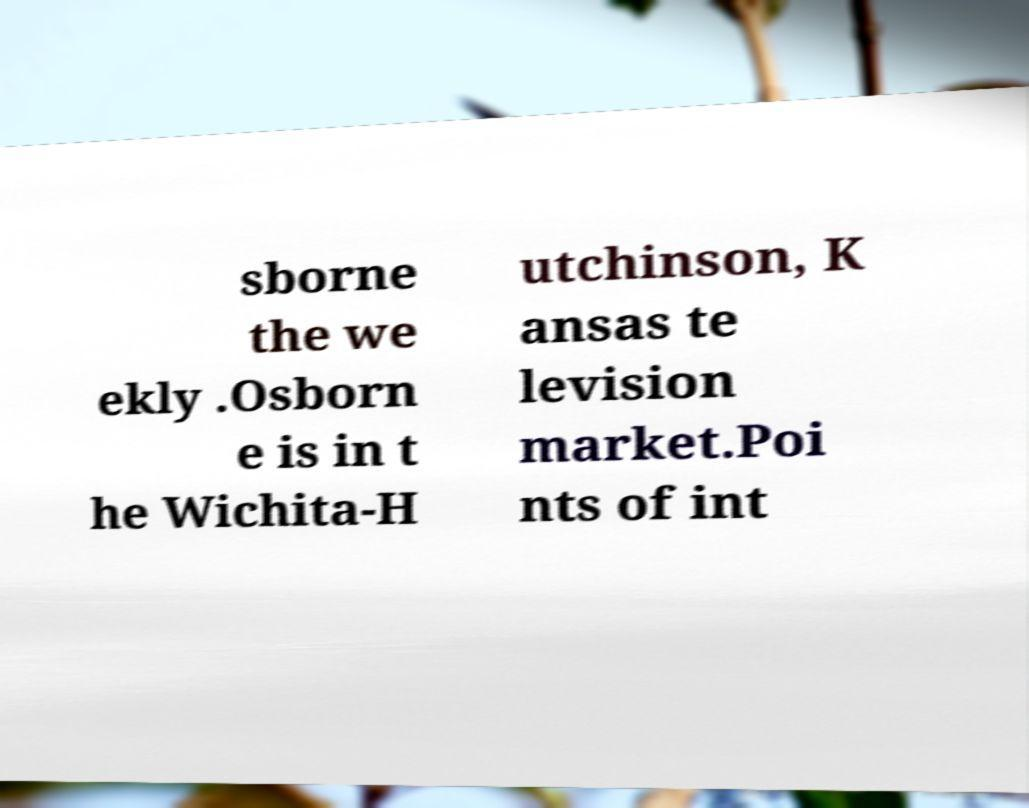Can you read and provide the text displayed in the image?This photo seems to have some interesting text. Can you extract and type it out for me? sborne the we ekly .Osborn e is in t he Wichita-H utchinson, K ansas te levision market.Poi nts of int 